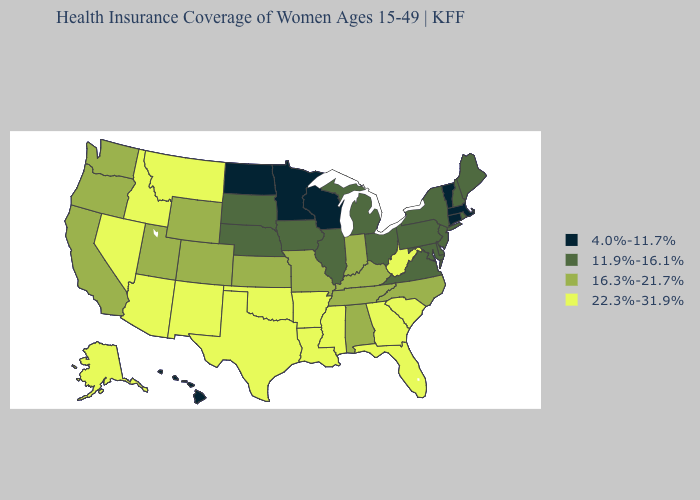What is the value of Alabama?
Short answer required. 16.3%-21.7%. What is the value of Missouri?
Quick response, please. 16.3%-21.7%. Does Missouri have the highest value in the MidWest?
Short answer required. Yes. What is the value of Maryland?
Concise answer only. 11.9%-16.1%. Name the states that have a value in the range 4.0%-11.7%?
Answer briefly. Connecticut, Hawaii, Massachusetts, Minnesota, North Dakota, Vermont, Wisconsin. What is the highest value in the MidWest ?
Short answer required. 16.3%-21.7%. What is the value of Maine?
Short answer required. 11.9%-16.1%. Name the states that have a value in the range 4.0%-11.7%?
Answer briefly. Connecticut, Hawaii, Massachusetts, Minnesota, North Dakota, Vermont, Wisconsin. Does the first symbol in the legend represent the smallest category?
Give a very brief answer. Yes. Does Maryland have the same value as Nevada?
Give a very brief answer. No. Which states have the lowest value in the USA?
Keep it brief. Connecticut, Hawaii, Massachusetts, Minnesota, North Dakota, Vermont, Wisconsin. Which states have the lowest value in the USA?
Write a very short answer. Connecticut, Hawaii, Massachusetts, Minnesota, North Dakota, Vermont, Wisconsin. Name the states that have a value in the range 16.3%-21.7%?
Give a very brief answer. Alabama, California, Colorado, Indiana, Kansas, Kentucky, Missouri, North Carolina, Oregon, Tennessee, Utah, Washington, Wyoming. Among the states that border North Dakota , which have the highest value?
Concise answer only. Montana. 